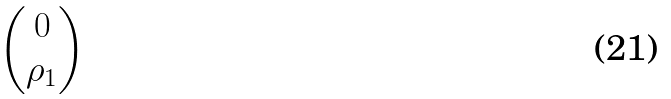<formula> <loc_0><loc_0><loc_500><loc_500>\begin{pmatrix} 0 \\ \rho _ { 1 } \end{pmatrix}</formula> 